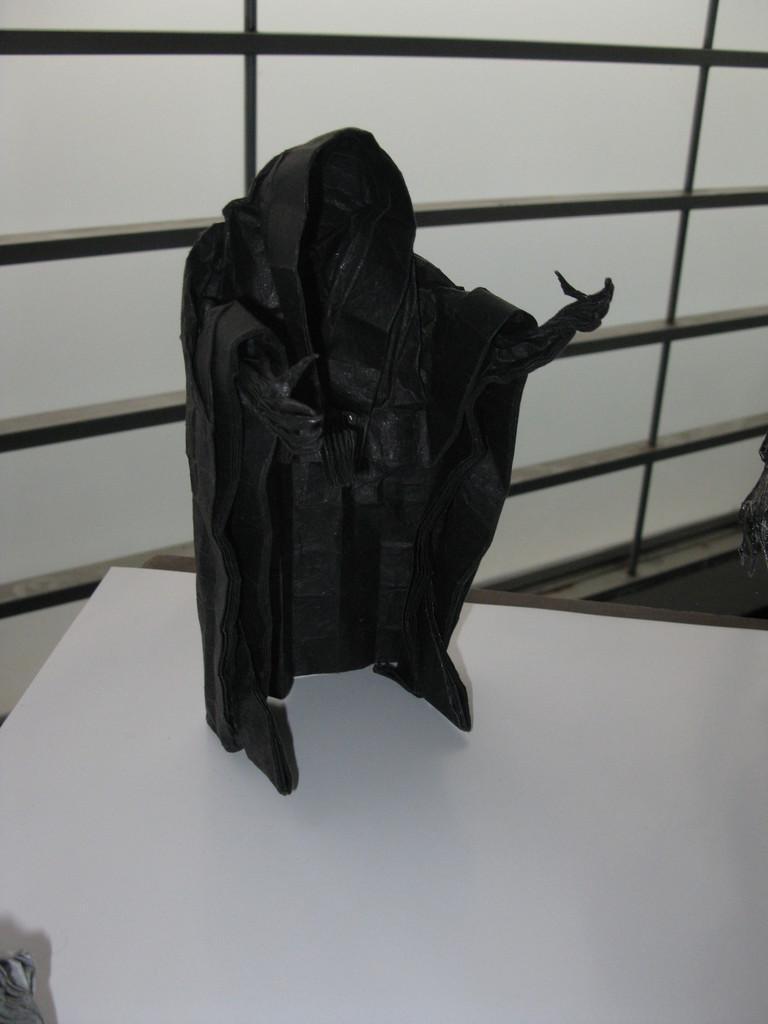Could you give a brief overview of what you see in this image? In the middle of this image, there is a black color object arranged on a white colored surface. In the background, there is a window. 